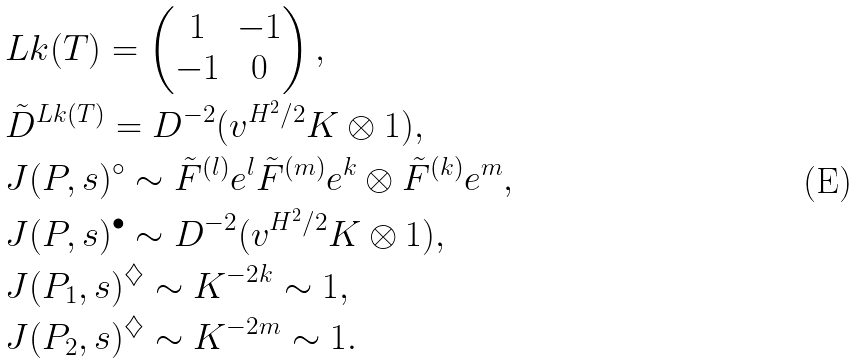Convert formula to latex. <formula><loc_0><loc_0><loc_500><loc_500>& L k ( T ) = \begin{pmatrix} 1 & - 1 \\ - 1 & 0 \end{pmatrix} , \\ & \tilde { D } ^ { L k ( T ) } = D ^ { - 2 } ( v ^ { H ^ { 2 } / 2 } K \otimes 1 ) , \\ & J ( P , s ) ^ { \circ } \sim \tilde { F } ^ { ( l ) } e ^ { l } \tilde { F } ^ { ( m ) } e ^ { k } \otimes \tilde { F } ^ { ( k ) } e ^ { m } , \\ & J ( P , s ) ^ { \bullet } \sim D ^ { - 2 } ( v ^ { H ^ { 2 } / 2 } K \otimes 1 ) , \\ & J ( P _ { 1 } , s ) ^ { \diamondsuit } \sim K ^ { - 2 k } \sim 1 , \\ & J ( P _ { 2 } , s ) ^ { \diamondsuit } \sim K ^ { - 2 m } \sim 1 .</formula> 